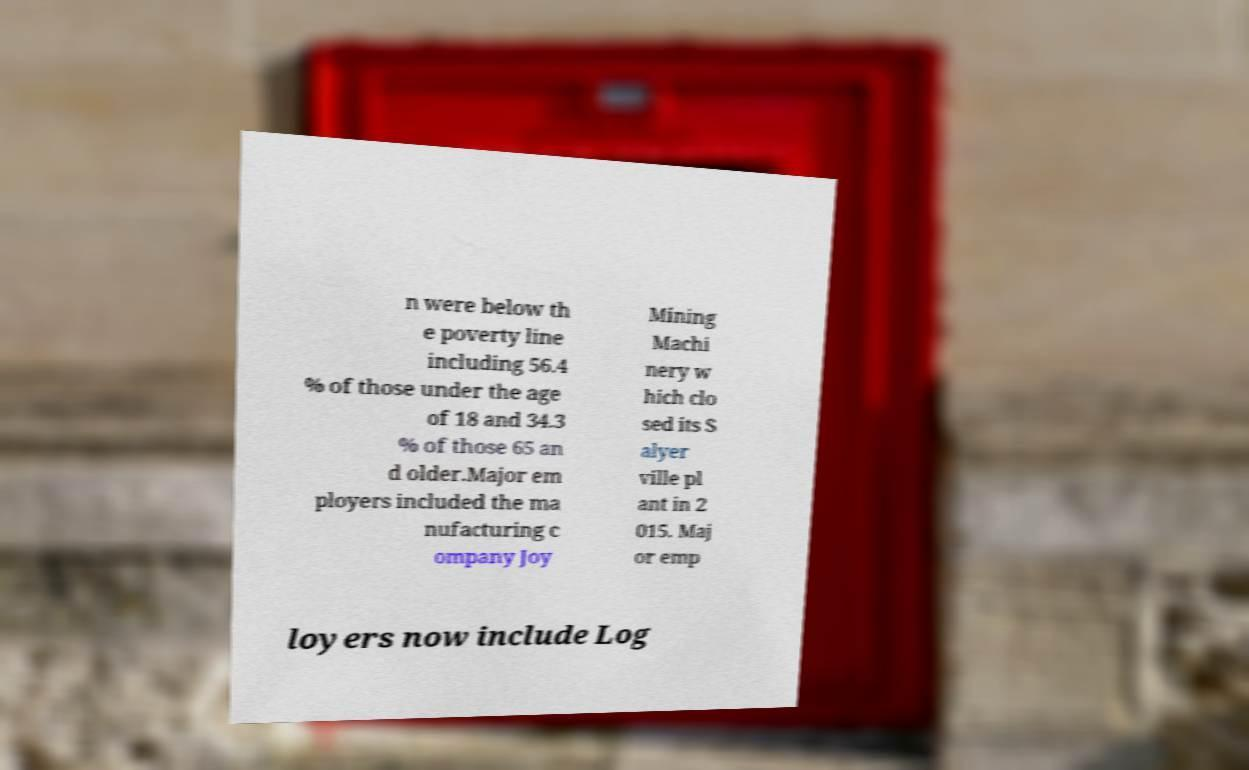Can you read and provide the text displayed in the image?This photo seems to have some interesting text. Can you extract and type it out for me? n were below th e poverty line including 56.4 % of those under the age of 18 and 34.3 % of those 65 an d older.Major em ployers included the ma nufacturing c ompany Joy Mining Machi nery w hich clo sed its S alyer ville pl ant in 2 015. Maj or emp loyers now include Log 